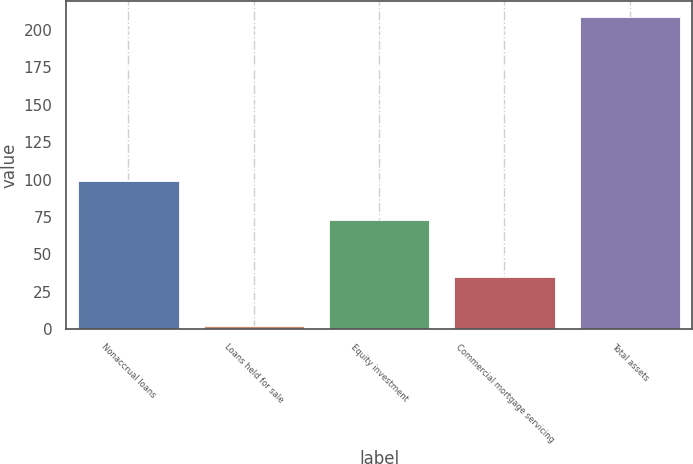Convert chart. <chart><loc_0><loc_0><loc_500><loc_500><bar_chart><fcel>Nonaccrual loans<fcel>Loans held for sale<fcel>Equity investment<fcel>Commercial mortgage servicing<fcel>Total assets<nl><fcel>99<fcel>2<fcel>73<fcel>35<fcel>209<nl></chart> 